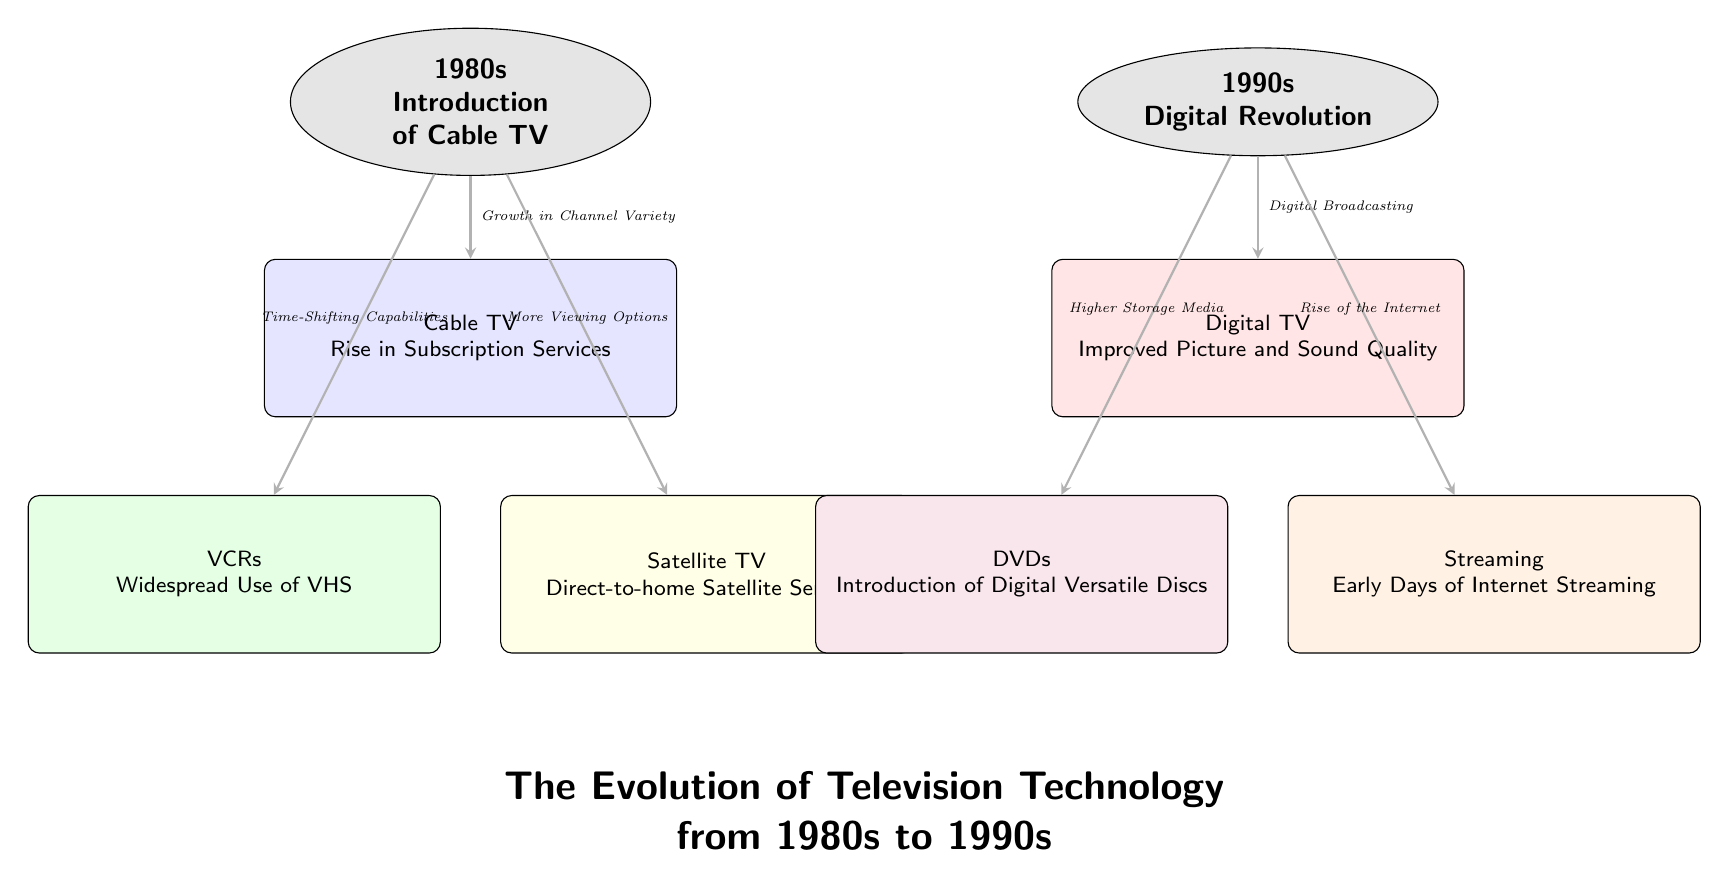What is the first era depicted in the diagram? The diagram clearly labels the first era as "1980s" with the text positioned at the top. This information indicates the starting point for the evolution of television technology represented in the diagram.
Answer: 1980s What technology is associated with increased viewing options in the 1980s? The diagram lists "Satellite TV" with an arrow pointing to it and a label stating "More Viewing Options." This directly links the technology to the characteristic mentioned.
Answer: Satellite TV How many technologies are listed under the 1990s? By counting the boxes listed under the 1990s era in the diagram, we see there are three technologies: Digital TV, DVDs, and Streaming. This total indicates the diversity of advancements during that era.
Answer: 3 Which technology from the 1980s is connected to time-shifting capabilities? The arrow from the "1980s" era to the "VCRs" box is labeled "Time-Shifting Capabilities," indicating that VCRs are directly associated with this function.
Answer: VCRs What is the direct impact of the digital revolution in the 1990s according to the diagram? The diagram states that the impact is seen in "Digital TV," which is connected by an arrow labeled "Digital Broadcasting." This indicates that the primary technological evolution in the 1990s was digital broadcasting through digital television.
Answer: Digital TV How does the introduction of DVDs relate to storage media? The diagram features a connection from the "1990s" to "DVDs," with the label "Higher Storage Media." This shows that DVDs were portrayed as an advancement in storage capacity during this period.
Answer: Higher Storage Media Which technological advancement in the 1990s is linked to the rise of the Internet? There is an arrow going from the "1990s" to the "Streaming" box labeled "Rise of the Internet." This implies that streaming technology during the 1990s was influenced by the growth of the Internet infrastructure.
Answer: Streaming What does the diagram indicate about the era of the 1980s regarding subscription services? The arrow from the "1980s" to the "Cable TV" box is labeled "Growth in Channel Variety," which directly relates the increased subscription services and variety provided by cable TV to that era.
Answer: Growth in Channel Variety What color represents Digital TV in the diagram? The box representing Digital TV is filled with red, indicating its designation as a significant advancement in the 1990s within the context of this diagram.
Answer: Red 